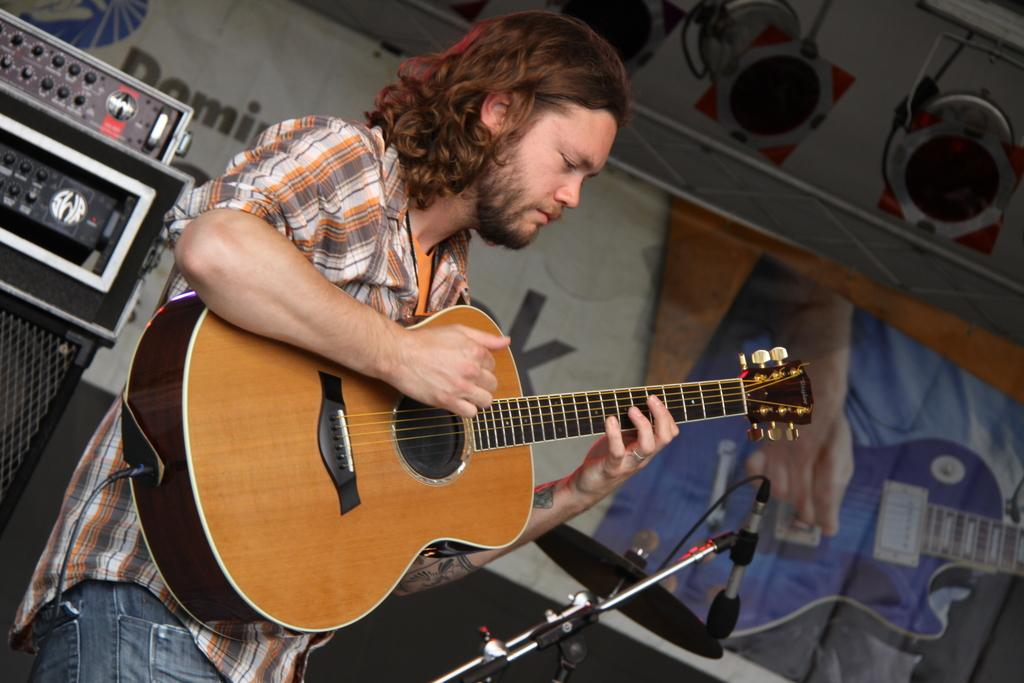Who is present in the image? There is a man in the image. What is the man holding in his hand? The man is holding a guitar in his hand. What other musical equipment can be seen in the image? There is a microphone and a microphone stand in the image. What type of attack is the man preparing to launch in the image? There is no indication of an attack in the image; the man is holding a guitar and there are musical equipment present. 